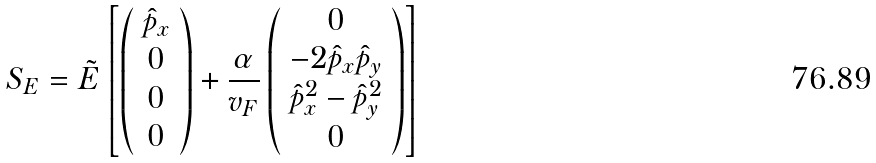<formula> <loc_0><loc_0><loc_500><loc_500>S _ { E } = \tilde { E } \left [ \left ( \begin{array} { c } \hat { p } _ { x } \\ 0 \\ 0 \\ 0 \\ \end{array} \right ) + \frac { \alpha } { v _ { F } } \left ( \begin{array} { c } 0 \\ - 2 \hat { p } _ { x } \hat { p } _ { y } \\ \hat { p } _ { x } ^ { 2 } - \hat { p } _ { y } ^ { 2 } \\ 0 \\ \end{array} \right ) \right ]</formula> 